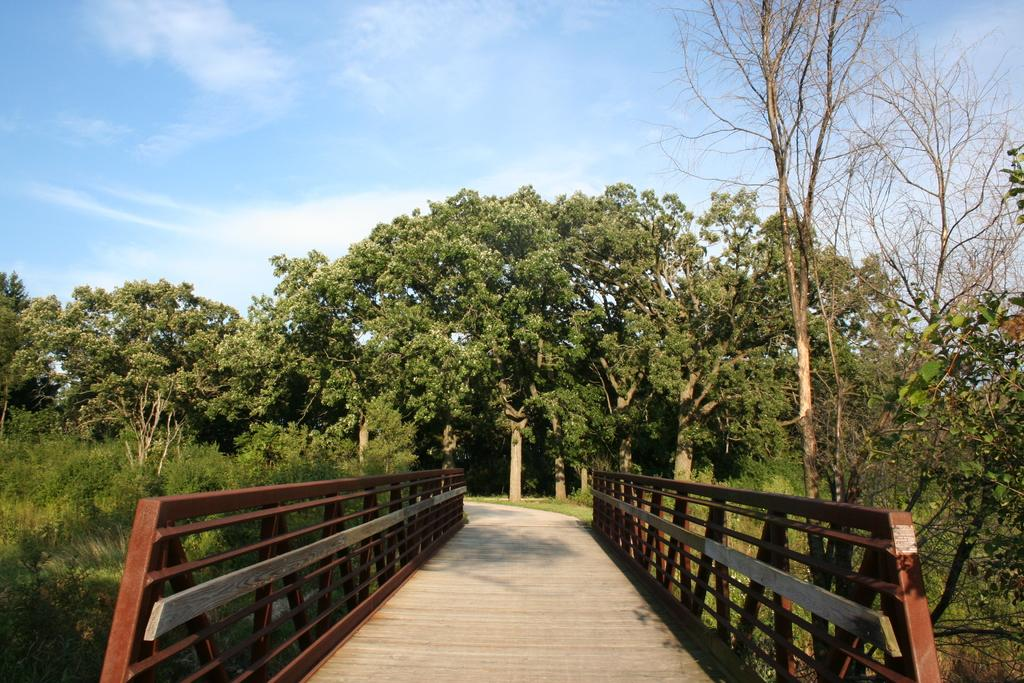What structure is present in the image? There is a bridge in the image. What feature can be seen on the bridge? The bridge has railings. What is located on the left side of the image? There are plants on the left side of the image. What can be seen in the background of the image? There are trees in the background of the image. How would you describe the sky in the image? The sky is cloudy in the image. What type of sugar is being used to sweeten the pipe in the image? There is no sugar or pipe present in the image; it features a bridge with railings, plants, trees, and a cloudy sky. 